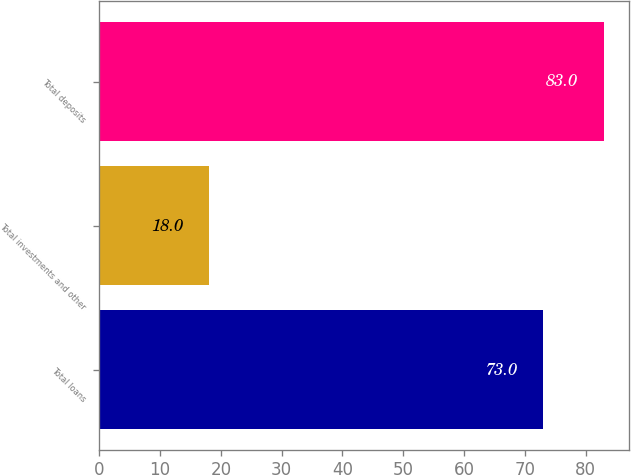Convert chart. <chart><loc_0><loc_0><loc_500><loc_500><bar_chart><fcel>Total loans<fcel>Total investments and other<fcel>Total deposits<nl><fcel>73<fcel>18<fcel>83<nl></chart> 